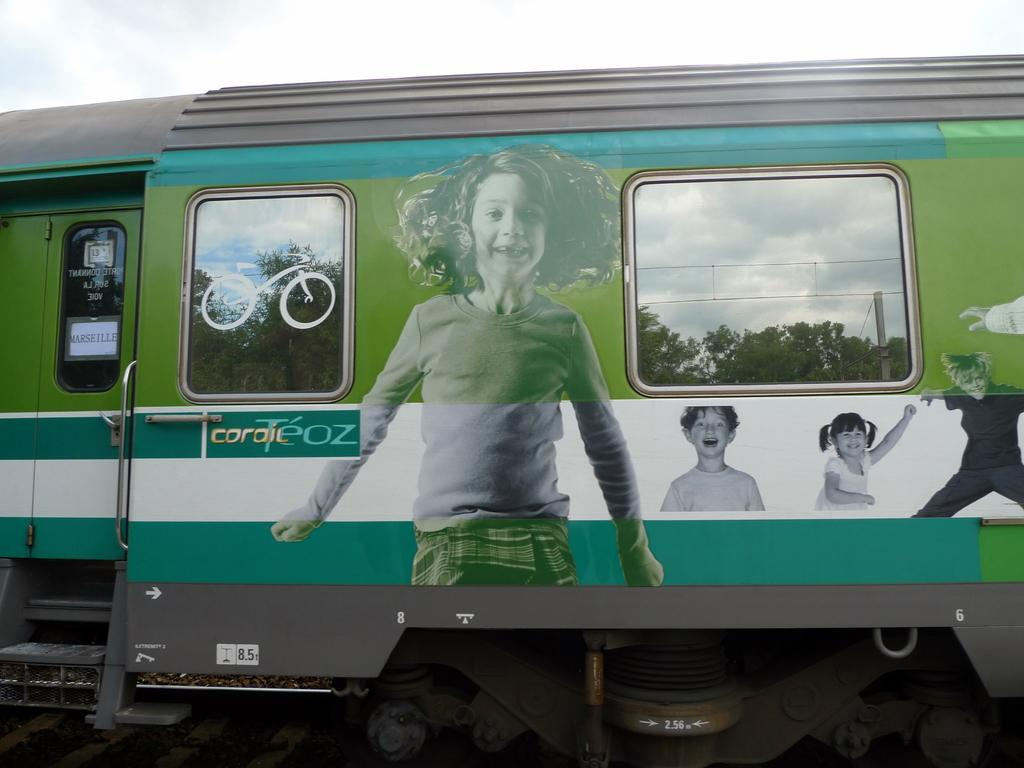What type of vehicle is in the image? There is a green color train in the image. What is the condition of the sky in the image? The sky is covered with clouds. What type of soda is being exchanged between the passengers on the train? There is no indication of passengers or soda in the image; it only features a green color train and a cloudy sky. 